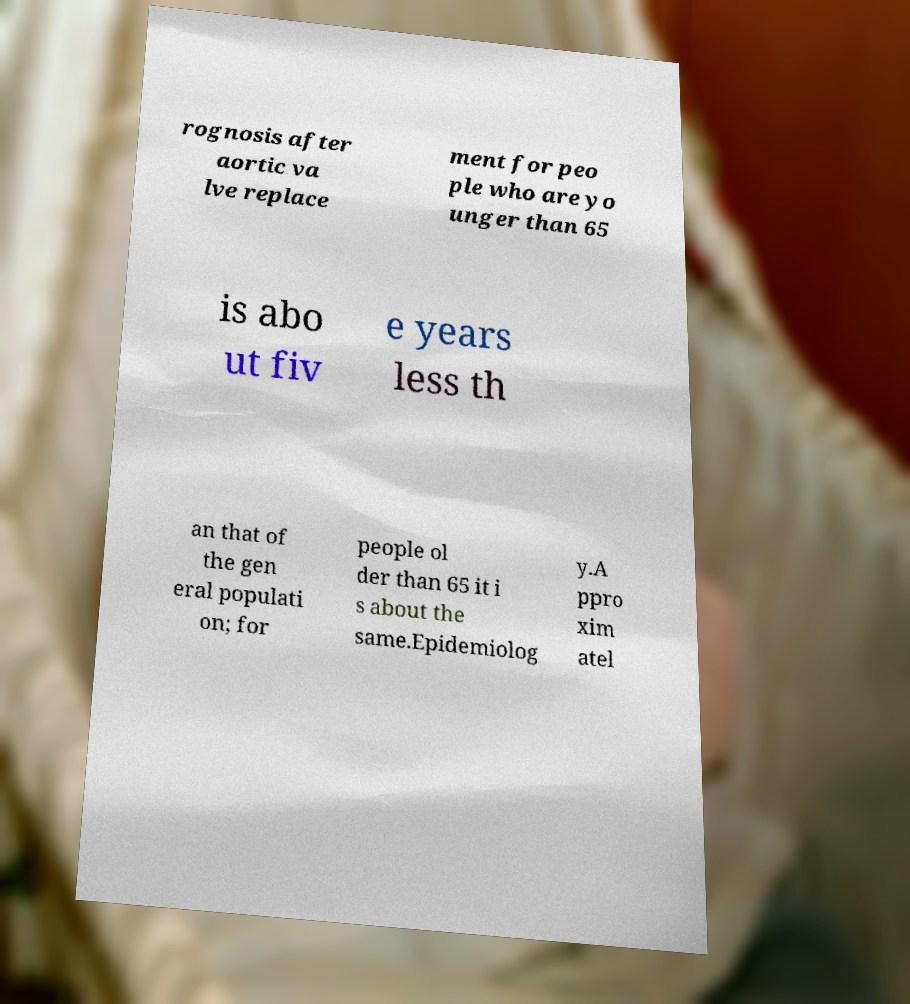Can you read and provide the text displayed in the image?This photo seems to have some interesting text. Can you extract and type it out for me? rognosis after aortic va lve replace ment for peo ple who are yo unger than 65 is abo ut fiv e years less th an that of the gen eral populati on; for people ol der than 65 it i s about the same.Epidemiolog y.A ppro xim atel 